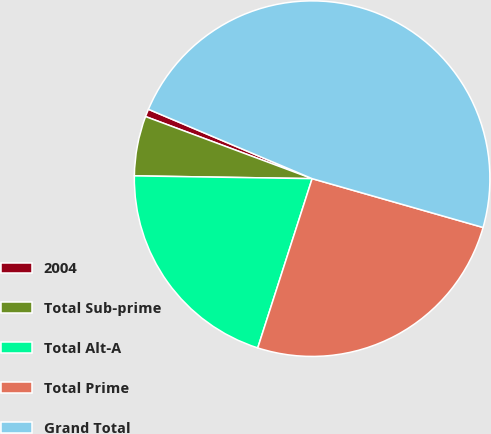Convert chart to OTSL. <chart><loc_0><loc_0><loc_500><loc_500><pie_chart><fcel>2004<fcel>Total Sub-prime<fcel>Total Alt-A<fcel>Total Prime<fcel>Grand Total<nl><fcel>0.7%<fcel>5.43%<fcel>20.3%<fcel>25.52%<fcel>48.05%<nl></chart> 